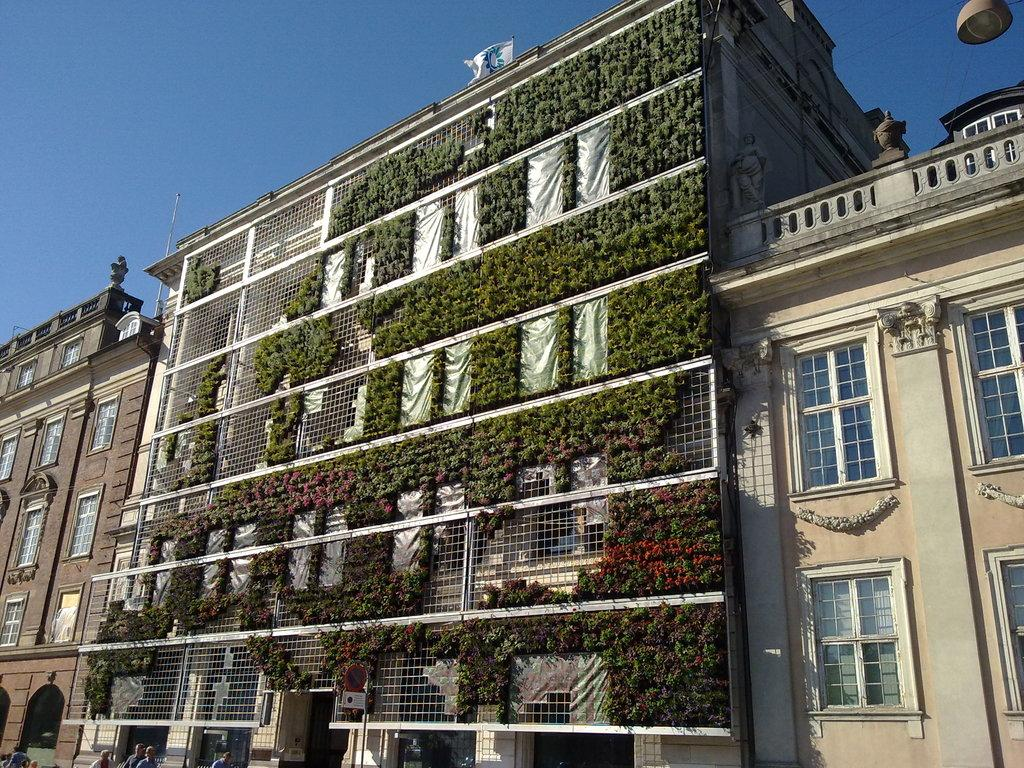What types of structures can be seen in the image? There are buildings in the image. What other elements are present in the image besides the buildings? There are plants, a pole, a grille, people, a board, a flag, and the sky visible in the image. Can you see a carpenter working on a project in the image? There is no carpenter or any indication of a project being worked on in the image. Are there any deer visible in the image? There are no deer present in the image. 